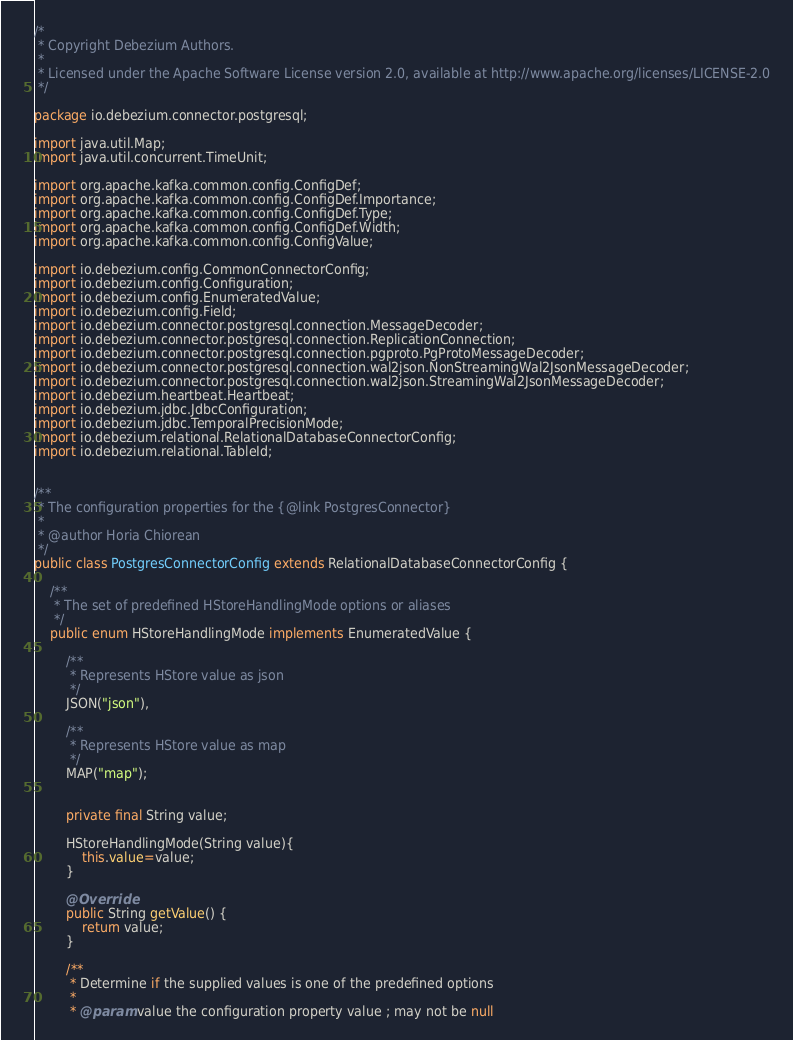Convert code to text. <code><loc_0><loc_0><loc_500><loc_500><_Java_>/*
 * Copyright Debezium Authors.
 *
 * Licensed under the Apache Software License version 2.0, available at http://www.apache.org/licenses/LICENSE-2.0
 */

package io.debezium.connector.postgresql;

import java.util.Map;
import java.util.concurrent.TimeUnit;

import org.apache.kafka.common.config.ConfigDef;
import org.apache.kafka.common.config.ConfigDef.Importance;
import org.apache.kafka.common.config.ConfigDef.Type;
import org.apache.kafka.common.config.ConfigDef.Width;
import org.apache.kafka.common.config.ConfigValue;

import io.debezium.config.CommonConnectorConfig;
import io.debezium.config.Configuration;
import io.debezium.config.EnumeratedValue;
import io.debezium.config.Field;
import io.debezium.connector.postgresql.connection.MessageDecoder;
import io.debezium.connector.postgresql.connection.ReplicationConnection;
import io.debezium.connector.postgresql.connection.pgproto.PgProtoMessageDecoder;
import io.debezium.connector.postgresql.connection.wal2json.NonStreamingWal2JsonMessageDecoder;
import io.debezium.connector.postgresql.connection.wal2json.StreamingWal2JsonMessageDecoder;
import io.debezium.heartbeat.Heartbeat;
import io.debezium.jdbc.JdbcConfiguration;
import io.debezium.jdbc.TemporalPrecisionMode;
import io.debezium.relational.RelationalDatabaseConnectorConfig;
import io.debezium.relational.TableId;


/**
 * The configuration properties for the {@link PostgresConnector}
 *
 * @author Horia Chiorean
 */
public class PostgresConnectorConfig extends RelationalDatabaseConnectorConfig {

    /**
     * The set of predefined HStoreHandlingMode options or aliases
     */
    public enum HStoreHandlingMode implements EnumeratedValue {

        /**
         * Represents HStore value as json
         */
        JSON("json"),

        /**
         * Represents HStore value as map
         */
        MAP("map");


        private final String value;

        HStoreHandlingMode(String value){
            this.value=value;
        }

        @Override
        public String getValue() {
            return value;
        }

        /**
         * Determine if the supplied values is one of the predefined options
         *
         * @param value the configuration property value ; may not be null</code> 